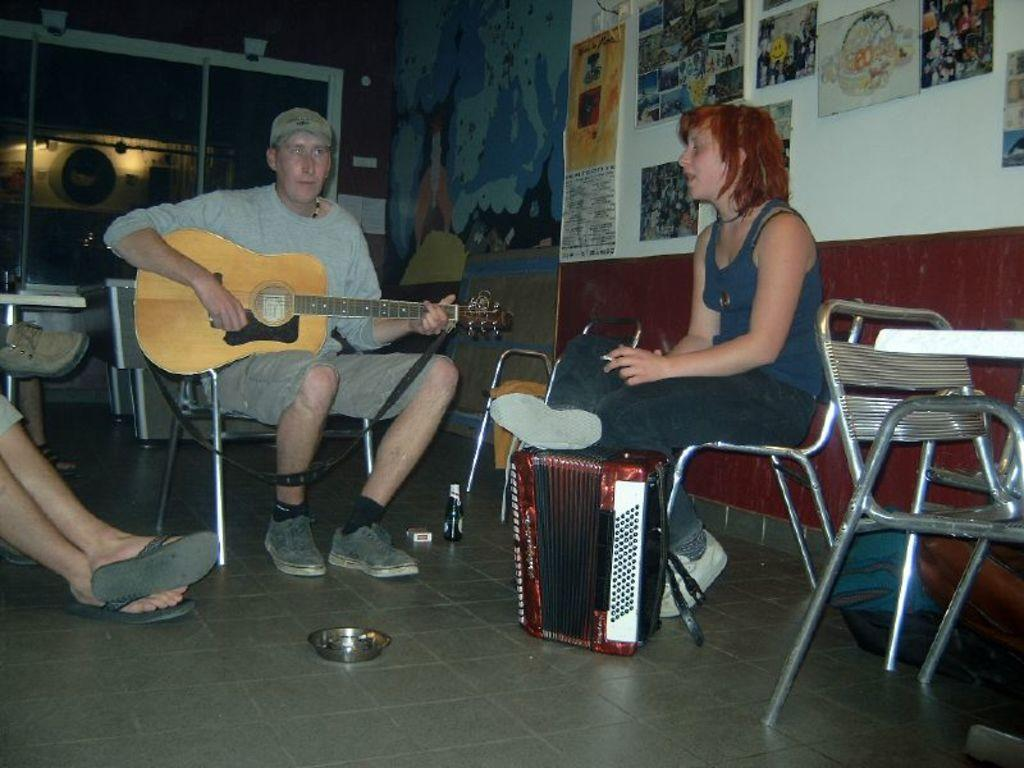How many people are sitting in the image? There are three persons sitting on chairs in the image. What is the person in the center doing? The person in the center is holding a guitar. What can be seen in the background of the image? There is a wall, a notice board, a light, and another chair in the background of the image. What type of plastic material is being destroyed in the image? There is no plastic material being destroyed in the image. Can you hear the voice of the person playing the guitar in the image? The image is a still photograph, so it does not capture sound or voices. 